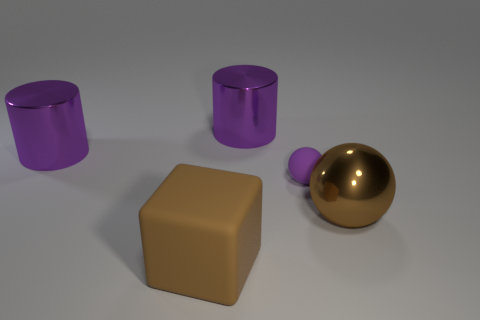Subtract 1 blocks. How many blocks are left? 0 Subtract all cyan cylinders. How many purple spheres are left? 1 Subtract 0 green cylinders. How many objects are left? 5 Subtract all blocks. How many objects are left? 4 Subtract all brown cylinders. Subtract all gray blocks. How many cylinders are left? 2 Subtract all big purple metallic objects. Subtract all purple metal cylinders. How many objects are left? 1 Add 4 large balls. How many large balls are left? 5 Add 1 tiny purple rubber spheres. How many tiny purple rubber spheres exist? 2 Add 3 big blue balls. How many objects exist? 8 